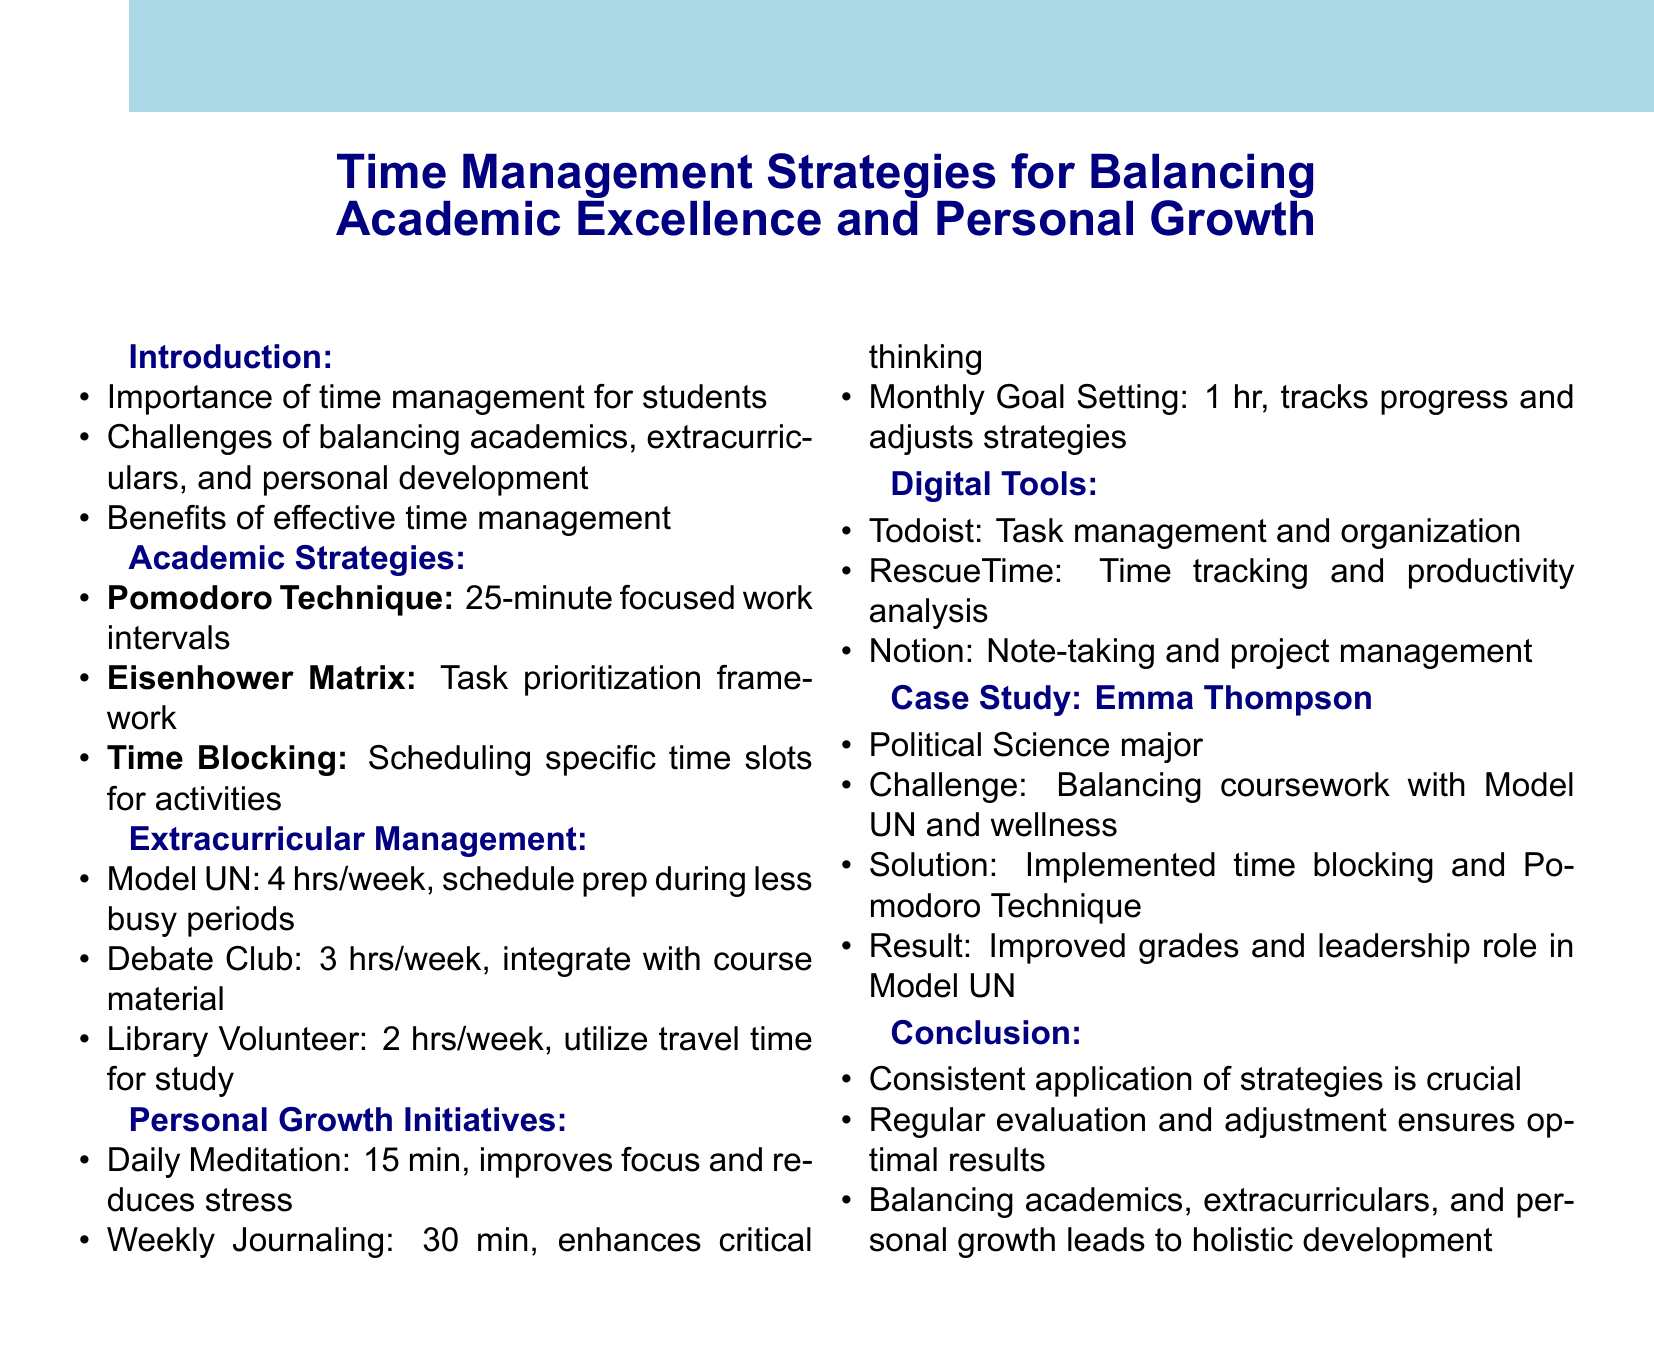What is the title of the document? The title is located at the beginning of the document and summarizes its main focus on time management strategies.
Answer: Time Management Strategies for Balancing Academic Excellence and Personal Growth What is the duration for daily meditation? The duration for daily meditation is specified in the section about personal growth initiatives, highlighting the time commitment for this activity.
Answer: 15 minutes Name one digital tool mentioned in the document. The document includes a section on digital tools with several examples provided for task management and organization.
Answer: Todoist What is the primary challenge faced by Emma Thompson? The challenge is outlined in the case study section and reflects the difficulties she's encountering in her academic and extracurricular life.
Answer: Balancing rigorous coursework with Model UN participation and personal wellness How many hours per week are allocated for the Debate Club? This information is found under the extracurricular management section, detailing time commitments for various activities.
Answer: 3 hours per week What is one benefit of weekly journal writing? The benefits of personal growth activities are detailed, providing insights on how each initiative contributes to a student's skills and well-being.
Answer: Enhance critical thinking and self-reflection skills Which time management strategy involves prioritizing tasks based on urgency and importance? The document describes various academic strategies, and this particular strategy is aimed at helping students organize their workload effectively.
Answer: Eisenhower Matrix What is the key takeaway regarding the application of time management strategies? The conclusion summarizes essential insights from the document, emphasizing consistent practices for optimal results in managing time.
Answer: Consistent application of time management strategies is crucial What is the duration for monthly goal setting and review? This information is specified in the personal growth initiatives section, showing the time frame allocated for this activity.
Answer: 1 hour 